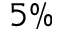Convert formula to latex. <formula><loc_0><loc_0><loc_500><loc_500>5 \%</formula> 